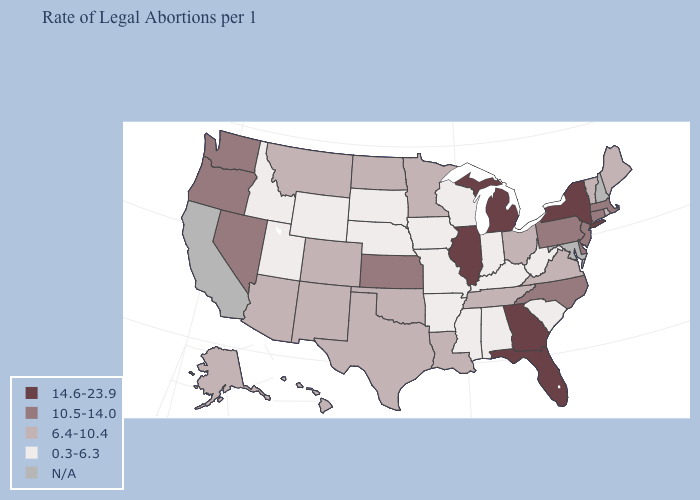Name the states that have a value in the range 0.3-6.3?
Answer briefly. Alabama, Arkansas, Idaho, Indiana, Iowa, Kentucky, Mississippi, Missouri, Nebraska, South Carolina, South Dakota, Utah, West Virginia, Wisconsin, Wyoming. Which states have the lowest value in the West?
Keep it brief. Idaho, Utah, Wyoming. Among the states that border Mississippi , which have the lowest value?
Quick response, please. Alabama, Arkansas. What is the value of Montana?
Be succinct. 6.4-10.4. Which states have the lowest value in the West?
Quick response, please. Idaho, Utah, Wyoming. What is the value of North Carolina?
Write a very short answer. 10.5-14.0. What is the value of Kentucky?
Give a very brief answer. 0.3-6.3. What is the lowest value in the West?
Write a very short answer. 0.3-6.3. Name the states that have a value in the range N/A?
Concise answer only. California, Maryland, New Hampshire. What is the lowest value in the USA?
Give a very brief answer. 0.3-6.3. What is the value of Georgia?
Concise answer only. 14.6-23.9. Name the states that have a value in the range 14.6-23.9?
Keep it brief. Florida, Georgia, Illinois, Michigan, New York. Which states hav the highest value in the MidWest?
Be succinct. Illinois, Michigan. What is the value of Washington?
Keep it brief. 10.5-14.0. 